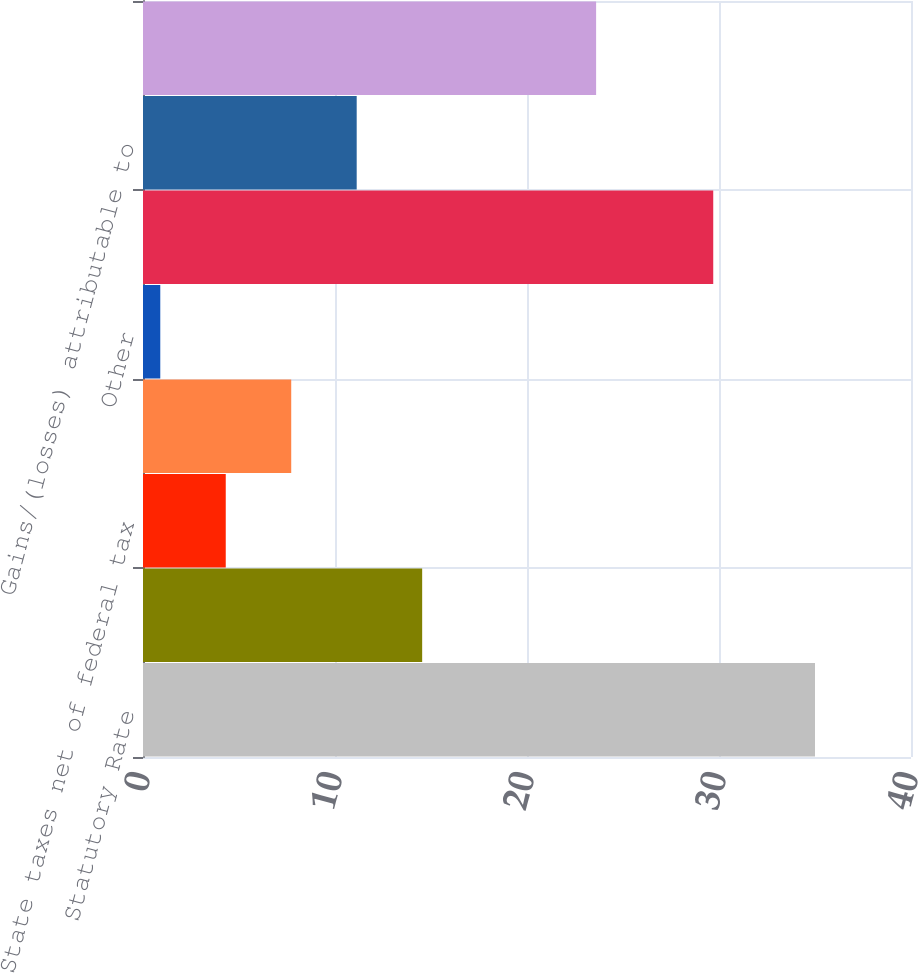<chart> <loc_0><loc_0><loc_500><loc_500><bar_chart><fcel>Statutory Rate<fcel>Foreign jurisdiction statutory<fcel>State taxes net of federal tax<fcel>Change in valuation allowance<fcel>Other<fcel>Effective tax rate (excluding<fcel>Gains/(losses) attributable to<fcel>Effective tax rate per<nl><fcel>35<fcel>14.54<fcel>4.31<fcel>7.72<fcel>0.9<fcel>29.7<fcel>11.13<fcel>23.6<nl></chart> 